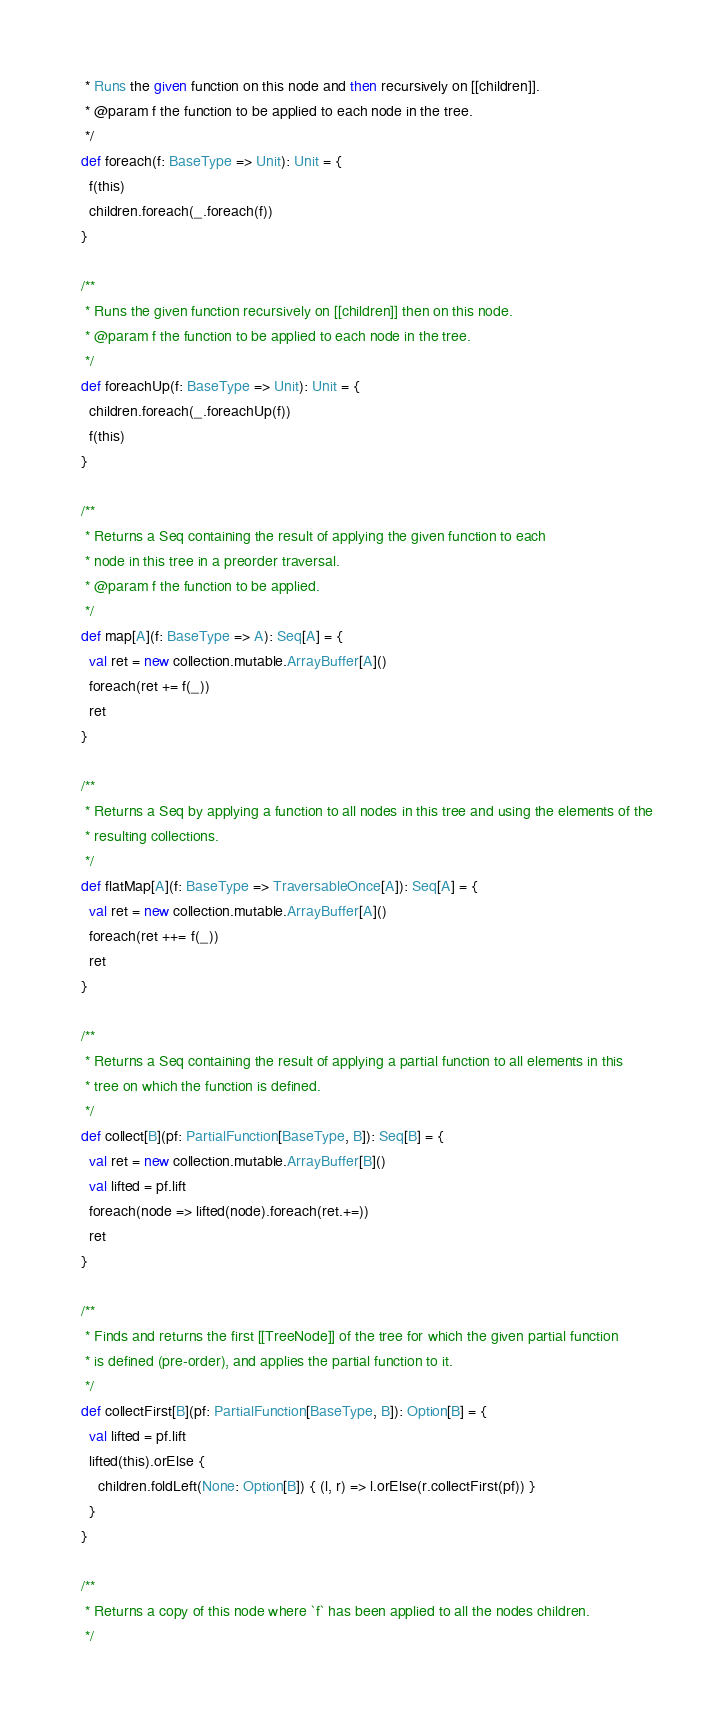Convert code to text. <code><loc_0><loc_0><loc_500><loc_500><_Scala_>   * Runs the given function on this node and then recursively on [[children]].
   * @param f the function to be applied to each node in the tree.
   */
  def foreach(f: BaseType => Unit): Unit = {
    f(this)
    children.foreach(_.foreach(f))
  }

  /**
   * Runs the given function recursively on [[children]] then on this node.
   * @param f the function to be applied to each node in the tree.
   */
  def foreachUp(f: BaseType => Unit): Unit = {
    children.foreach(_.foreachUp(f))
    f(this)
  }

  /**
   * Returns a Seq containing the result of applying the given function to each
   * node in this tree in a preorder traversal.
   * @param f the function to be applied.
   */
  def map[A](f: BaseType => A): Seq[A] = {
    val ret = new collection.mutable.ArrayBuffer[A]()
    foreach(ret += f(_))
    ret
  }

  /**
   * Returns a Seq by applying a function to all nodes in this tree and using the elements of the
   * resulting collections.
   */
  def flatMap[A](f: BaseType => TraversableOnce[A]): Seq[A] = {
    val ret = new collection.mutable.ArrayBuffer[A]()
    foreach(ret ++= f(_))
    ret
  }

  /**
   * Returns a Seq containing the result of applying a partial function to all elements in this
   * tree on which the function is defined.
   */
  def collect[B](pf: PartialFunction[BaseType, B]): Seq[B] = {
    val ret = new collection.mutable.ArrayBuffer[B]()
    val lifted = pf.lift
    foreach(node => lifted(node).foreach(ret.+=))
    ret
  }

  /**
   * Finds and returns the first [[TreeNode]] of the tree for which the given partial function
   * is defined (pre-order), and applies the partial function to it.
   */
  def collectFirst[B](pf: PartialFunction[BaseType, B]): Option[B] = {
    val lifted = pf.lift
    lifted(this).orElse {
      children.foldLeft(None: Option[B]) { (l, r) => l.orElse(r.collectFirst(pf)) }
    }
  }

  /**
   * Returns a copy of this node where `f` has been applied to all the nodes children.
   */</code> 